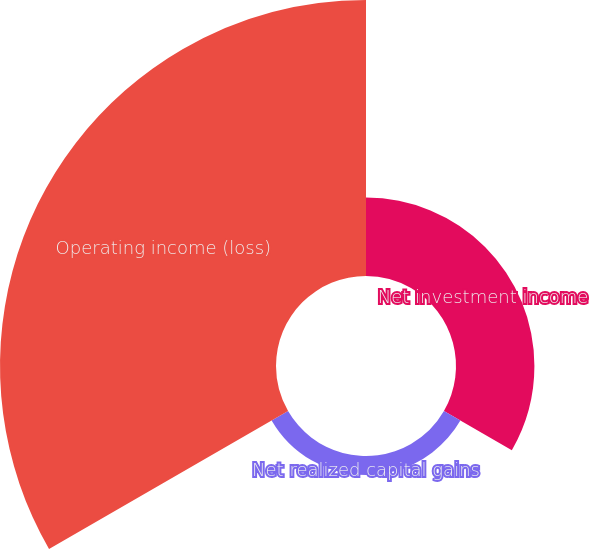Convert chart. <chart><loc_0><loc_0><loc_500><loc_500><pie_chart><fcel>Net investment income<fcel>Net realized capital gains<fcel>Operating income (loss)<nl><fcel>21.0%<fcel>5.08%<fcel>73.92%<nl></chart> 